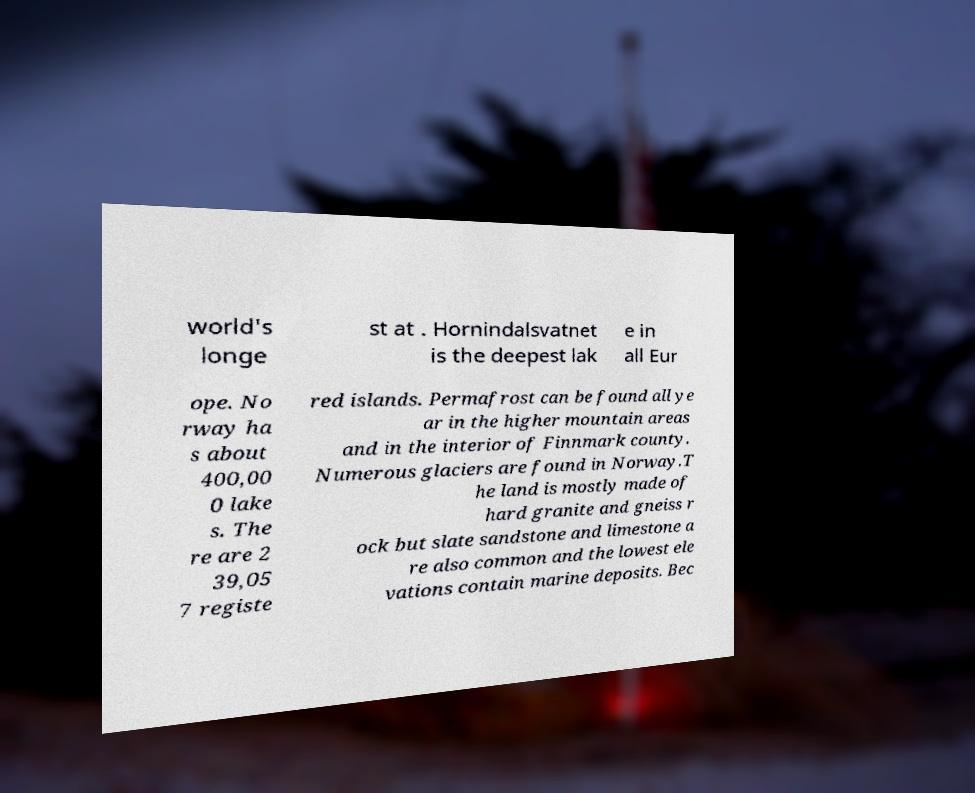I need the written content from this picture converted into text. Can you do that? world's longe st at . Hornindalsvatnet is the deepest lak e in all Eur ope. No rway ha s about 400,00 0 lake s. The re are 2 39,05 7 registe red islands. Permafrost can be found all ye ar in the higher mountain areas and in the interior of Finnmark county. Numerous glaciers are found in Norway.T he land is mostly made of hard granite and gneiss r ock but slate sandstone and limestone a re also common and the lowest ele vations contain marine deposits. Bec 